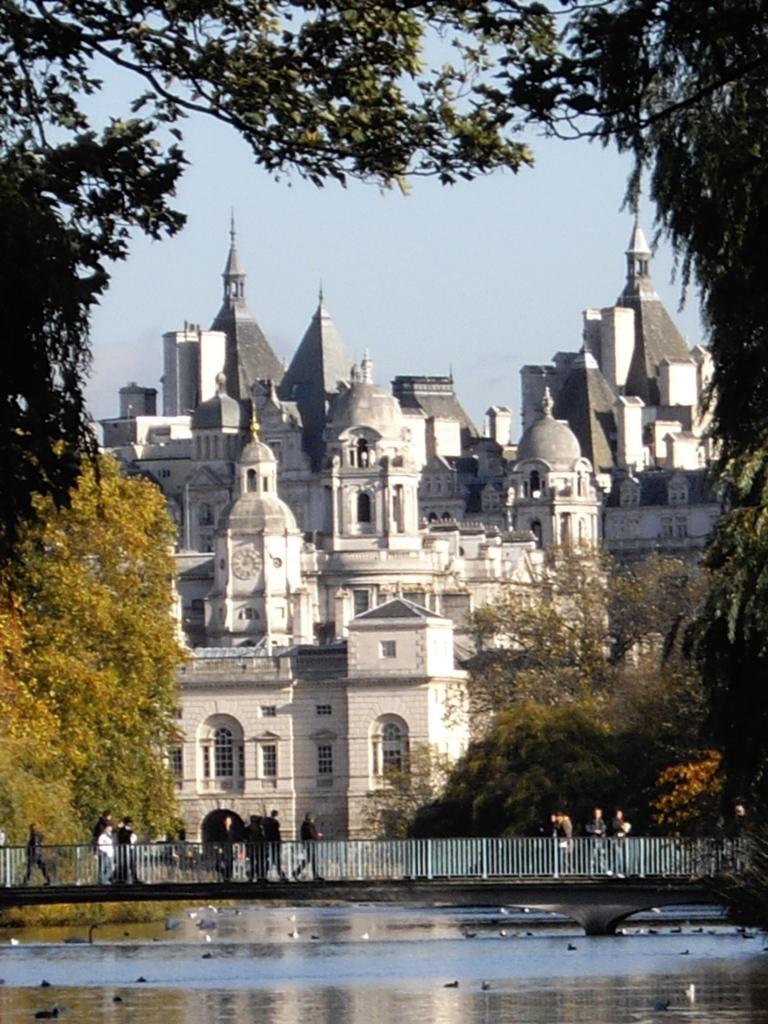Can you describe this image briefly? In the center of the image there is a building. At the bottom there is water and we can see a bridge. There are people walking on the bridge. In the background there are trees and sky. 